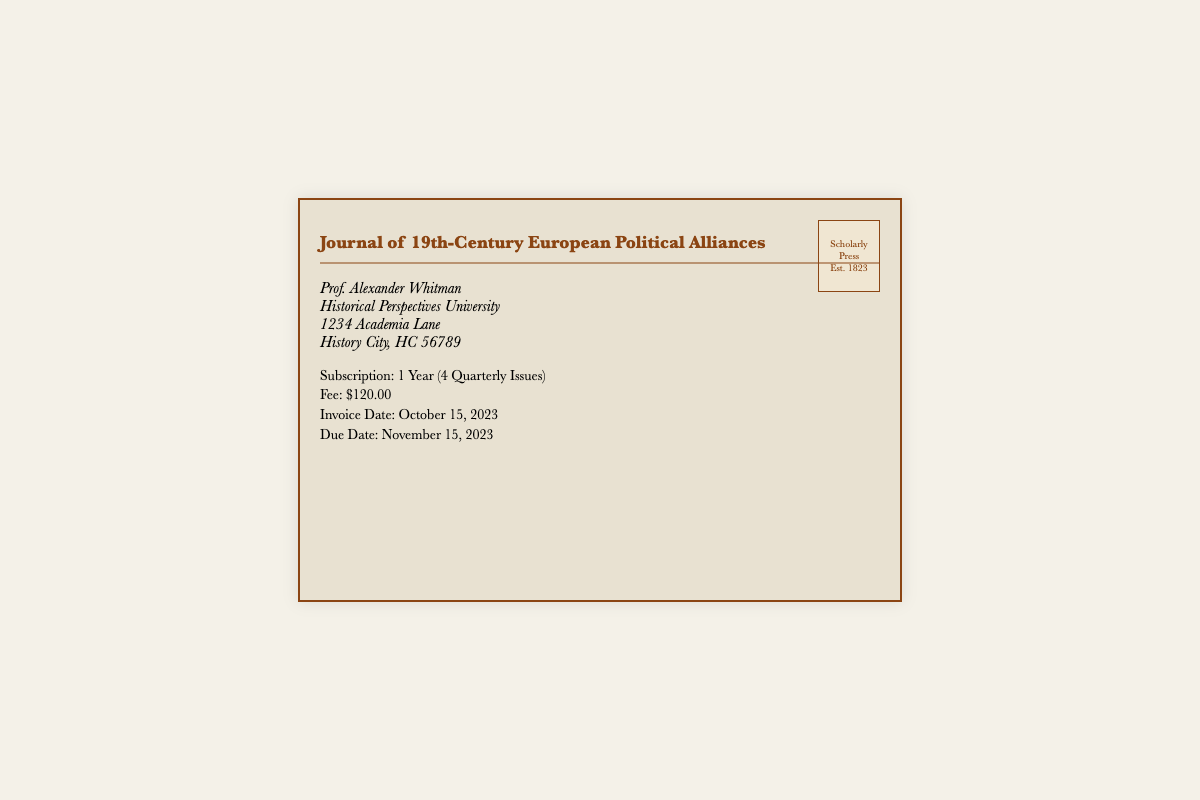What is the title of the journal? The title of the journal is stated prominently at the top of the envelope.
Answer: Journal of 19th-Century European Political Alliances Who is the recipient of the invoice? The recipient's name is listed in the address section of the envelope.
Answer: Prof. Alexander Whitman What is the subscription fee? The subscription fee is clearly mentioned in the details section.
Answer: $120.00 What is the due date for payment? The due date is specified in the details section of the envelope.
Answer: November 15, 2023 How many issues are included in the subscription? The number of issues is mentioned alongside the subscription duration in the details.
Answer: 4 Quarterly Issues What is the invoice date? The invoice date is indicated in the details section of the envelope.
Answer: October 15, 2023 What is the name of the press that published the journal? The name of the press is found in the stamp section of the envelope.
Answer: Scholarly Press When was the press established? The establishment year is mentioned in the stamp section.
Answer: 1823 What university is Prof. Whitman affiliated with? The university name is referenced in the address section of the envelope.
Answer: Historical Perspectives University 